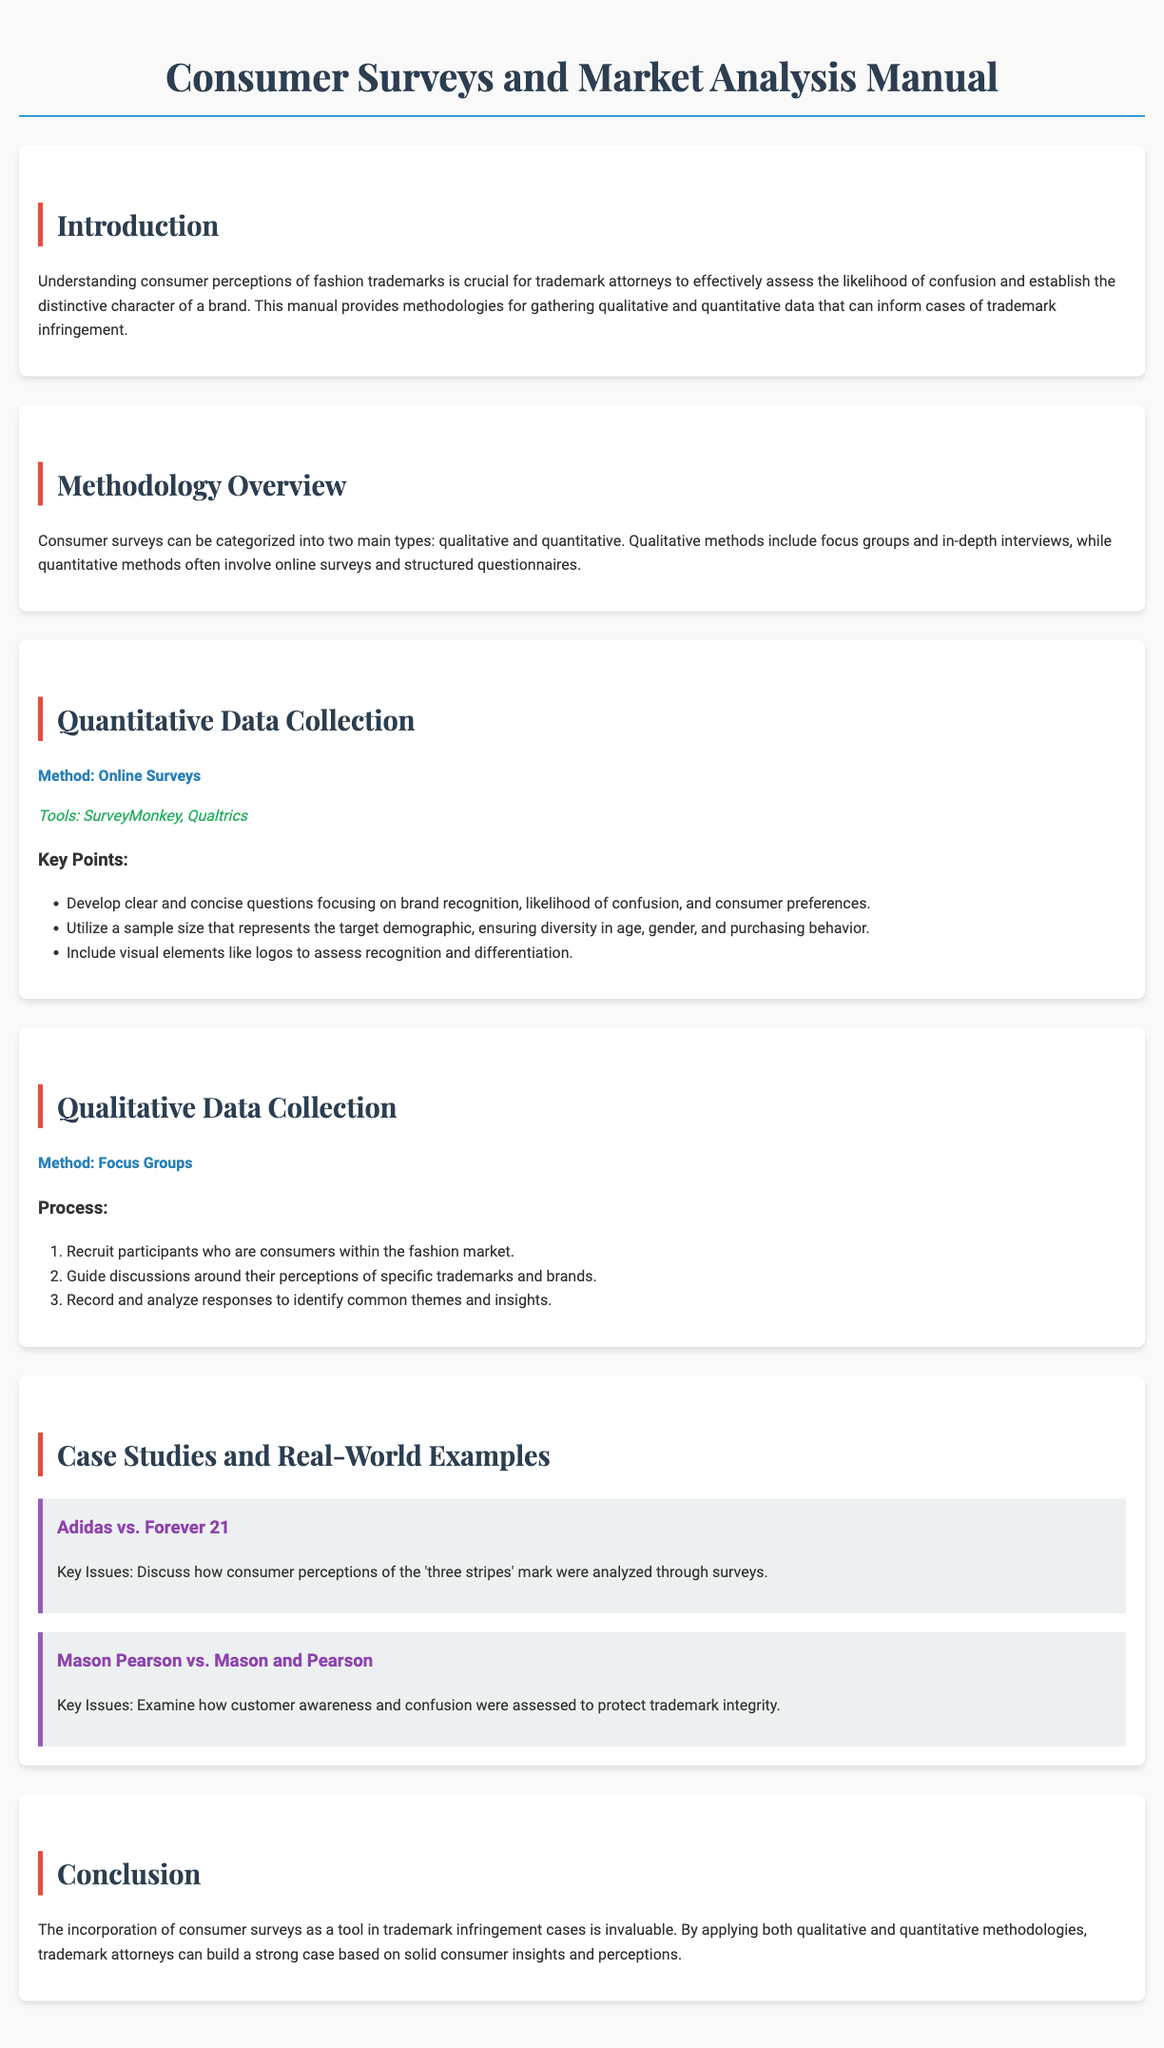What are the two main types of consumer surveys? The document categorizes consumer surveys into two main types: qualitative and quantitative.
Answer: qualitative and quantitative What tools are suggested for online surveys? The manual recommends using SurveyMonkey and Qualtrics for conducting online surveys.
Answer: SurveyMonkey, Qualtrics What is a key point for quantitative data collection? A key point is to develop clear and concise questions focusing on brand recognition, likelihood of confusion, and consumer preferences.
Answer: clear and concise questions How many steps are listed in the focus groups process? The document outlines three specific steps in the focus groups process for qualitative data collection.
Answer: three What example is provided for a case study related to trademarks? The manual includes a case study on Adidas vs. Forever 21 to discuss consumer perceptions.
Answer: Adidas vs. Forever 21 What should be included in qualitative discussions? Qualitative discussions should guide participants' perceptions of specific trademarks and brands.
Answer: perceptions of specific trademarks and brands What aspect is crucial for trademark attorneys according to the introduction? Understanding consumer perceptions of fashion trademarks is crucial for trademark attorneys.
Answer: consumer perceptions What does the conclusion state about consumer surveys? The conclusion states that incorporating consumer surveys is invaluable for trademark infringement cases.
Answer: invaluable 